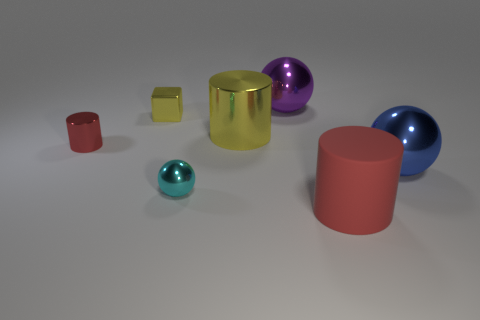There is a purple object that is the same shape as the blue metallic object; what is its size?
Provide a short and direct response. Large. What number of yellow metal cubes are right of the large shiny sphere that is right of the large object that is behind the yellow block?
Your response must be concise. 0. What number of cubes are either brown matte objects or blue metallic things?
Your answer should be very brief. 0. There is a large shiny ball that is behind the metallic cylinder right of the tiny yellow metallic cube left of the purple sphere; what color is it?
Ensure brevity in your answer.  Purple. How many other things are there of the same size as the red rubber cylinder?
Offer a terse response. 3. Are there any other things that have the same shape as the blue thing?
Your response must be concise. Yes. There is a big metallic thing that is the same shape as the red rubber object; what color is it?
Keep it short and to the point. Yellow. There is another cylinder that is made of the same material as the big yellow cylinder; what is its color?
Offer a very short reply. Red. Is the number of metal balls that are on the left side of the small cyan metal sphere the same as the number of tiny yellow metallic cubes?
Your answer should be very brief. No. There is a red cylinder to the left of the purple shiny thing; does it have the same size as the big red cylinder?
Offer a terse response. No. 